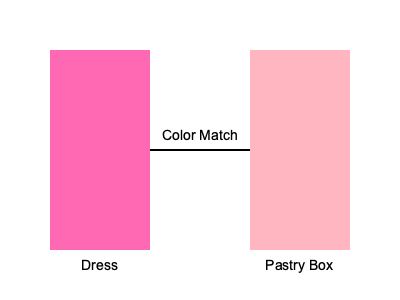Which color would be the best choice for a pastry box to complement a hot pink dress in your boutique display? To determine the best color for a pastry box to complement a hot pink dress, we need to consider color theory and visual merchandising principles:

1. Identify the main color: The dress is hot pink (#FF69B4).

2. Consider color harmony:
   a) Monochromatic: Using different shades of pink
   b) Analogous: Colors adjacent to pink on the color wheel (e.g., light purple or coral)
   c) Complementary: Opposite color on the color wheel (light green)

3. Factor in the boutique aesthetic:
   a) Elegant and cohesive look
   b) Avoid overwhelming or clashing colors

4. Consider pastry presentation:
   a) Light colors can make pastries look fresh and appetizing
   b) Soft colors won't compete with the vibrant dress

5. Best choice: A lighter shade of pink (#FFB6C1, light pink)
   - Creates a monochromatic color scheme
   - Maintains elegance and cohesion
   - Doesn't overpower the dress or pastries
   - Enhances the overall visual appeal of the display
Answer: Light pink (#FFB6C1) 